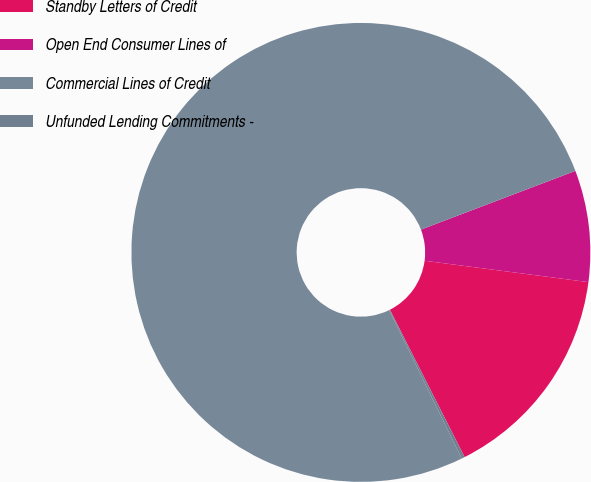<chart> <loc_0><loc_0><loc_500><loc_500><pie_chart><fcel>Standby Letters of Credit<fcel>Open End Consumer Lines of<fcel>Commercial Lines of Credit<fcel>Unfunded Lending Commitments -<nl><fcel>15.47%<fcel>7.85%<fcel>76.46%<fcel>0.22%<nl></chart> 